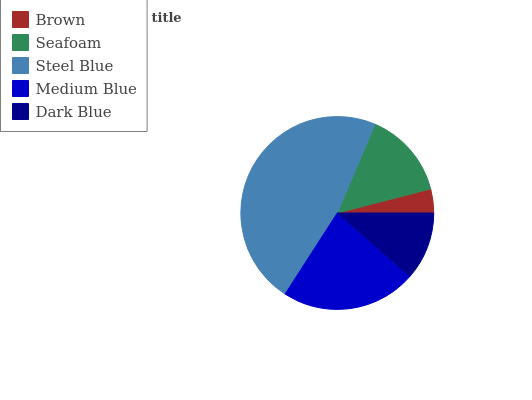Is Brown the minimum?
Answer yes or no. Yes. Is Steel Blue the maximum?
Answer yes or no. Yes. Is Seafoam the minimum?
Answer yes or no. No. Is Seafoam the maximum?
Answer yes or no. No. Is Seafoam greater than Brown?
Answer yes or no. Yes. Is Brown less than Seafoam?
Answer yes or no. Yes. Is Brown greater than Seafoam?
Answer yes or no. No. Is Seafoam less than Brown?
Answer yes or no. No. Is Seafoam the high median?
Answer yes or no. Yes. Is Seafoam the low median?
Answer yes or no. Yes. Is Brown the high median?
Answer yes or no. No. Is Steel Blue the low median?
Answer yes or no. No. 